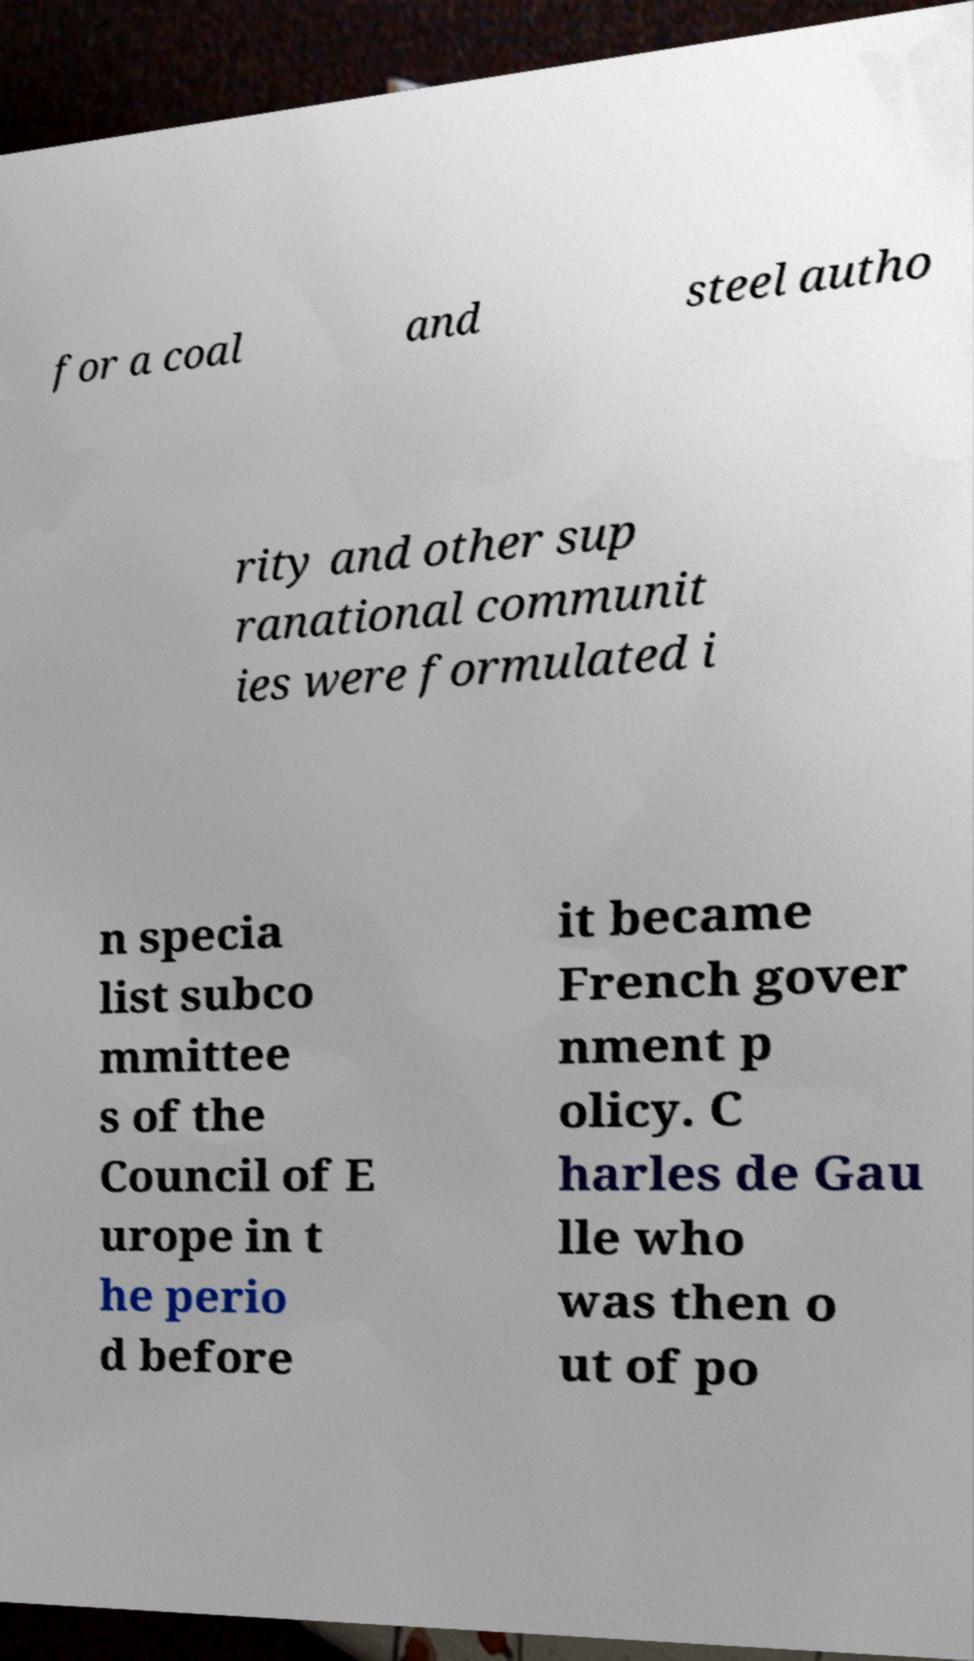I need the written content from this picture converted into text. Can you do that? for a coal and steel autho rity and other sup ranational communit ies were formulated i n specia list subco mmittee s of the Council of E urope in t he perio d before it became French gover nment p olicy. C harles de Gau lle who was then o ut of po 